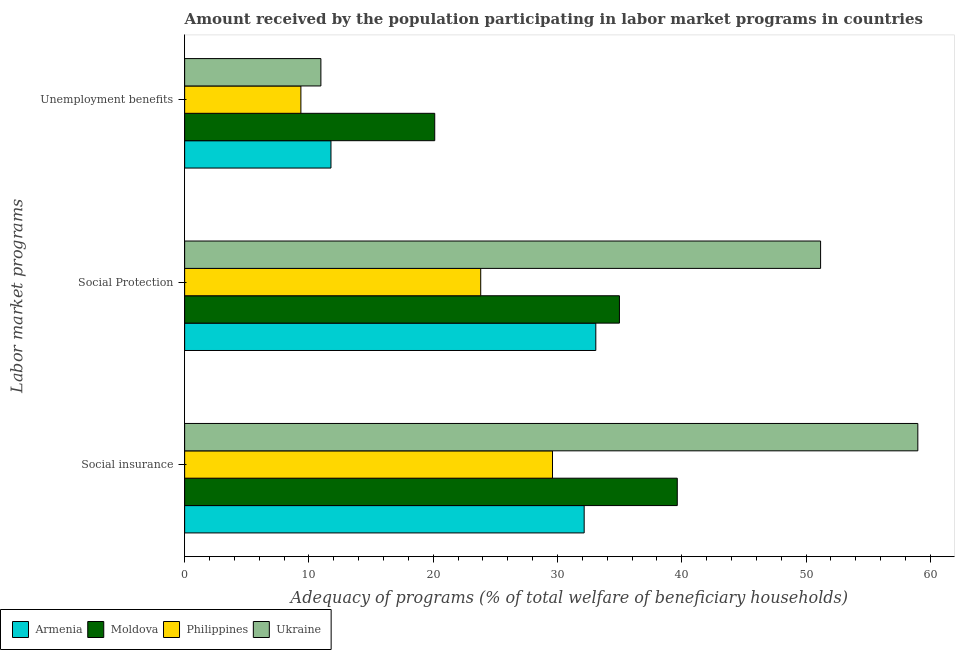Are the number of bars per tick equal to the number of legend labels?
Keep it short and to the point. Yes. Are the number of bars on each tick of the Y-axis equal?
Ensure brevity in your answer.  Yes. How many bars are there on the 1st tick from the top?
Offer a very short reply. 4. How many bars are there on the 1st tick from the bottom?
Offer a terse response. 4. What is the label of the 3rd group of bars from the top?
Make the answer very short. Social insurance. What is the amount received by the population participating in unemployment benefits programs in Moldova?
Provide a succinct answer. 20.12. Across all countries, what is the maximum amount received by the population participating in social insurance programs?
Provide a succinct answer. 58.99. Across all countries, what is the minimum amount received by the population participating in social insurance programs?
Provide a succinct answer. 29.6. In which country was the amount received by the population participating in unemployment benefits programs maximum?
Provide a short and direct response. Moldova. What is the total amount received by the population participating in social insurance programs in the graph?
Keep it short and to the point. 160.38. What is the difference between the amount received by the population participating in social protection programs in Philippines and that in Armenia?
Give a very brief answer. -9.26. What is the difference between the amount received by the population participating in social insurance programs in Armenia and the amount received by the population participating in unemployment benefits programs in Philippines?
Keep it short and to the point. 22.79. What is the average amount received by the population participating in unemployment benefits programs per country?
Offer a terse response. 13.05. What is the difference between the amount received by the population participating in unemployment benefits programs and amount received by the population participating in social protection programs in Armenia?
Provide a short and direct response. -21.31. In how many countries, is the amount received by the population participating in unemployment benefits programs greater than 38 %?
Provide a succinct answer. 0. What is the ratio of the amount received by the population participating in social protection programs in Ukraine to that in Moldova?
Ensure brevity in your answer.  1.46. Is the amount received by the population participating in social protection programs in Philippines less than that in Armenia?
Your answer should be very brief. Yes. Is the difference between the amount received by the population participating in social insurance programs in Ukraine and Armenia greater than the difference between the amount received by the population participating in unemployment benefits programs in Ukraine and Armenia?
Offer a very short reply. Yes. What is the difference between the highest and the second highest amount received by the population participating in social insurance programs?
Ensure brevity in your answer.  19.36. What is the difference between the highest and the lowest amount received by the population participating in social protection programs?
Provide a short and direct response. 27.35. In how many countries, is the amount received by the population participating in social insurance programs greater than the average amount received by the population participating in social insurance programs taken over all countries?
Give a very brief answer. 1. Is the sum of the amount received by the population participating in social insurance programs in Ukraine and Philippines greater than the maximum amount received by the population participating in unemployment benefits programs across all countries?
Keep it short and to the point. Yes. What does the 2nd bar from the top in Social Protection represents?
Your answer should be very brief. Philippines. What does the 4th bar from the bottom in Social Protection represents?
Make the answer very short. Ukraine. Is it the case that in every country, the sum of the amount received by the population participating in social insurance programs and amount received by the population participating in social protection programs is greater than the amount received by the population participating in unemployment benefits programs?
Keep it short and to the point. Yes. How many bars are there?
Offer a very short reply. 12. Are the values on the major ticks of X-axis written in scientific E-notation?
Make the answer very short. No. Does the graph contain any zero values?
Give a very brief answer. No. Where does the legend appear in the graph?
Make the answer very short. Bottom left. How are the legend labels stacked?
Give a very brief answer. Horizontal. What is the title of the graph?
Your answer should be compact. Amount received by the population participating in labor market programs in countries. Does "Dominica" appear as one of the legend labels in the graph?
Offer a terse response. No. What is the label or title of the X-axis?
Your answer should be compact. Adequacy of programs (% of total welfare of beneficiary households). What is the label or title of the Y-axis?
Your answer should be very brief. Labor market programs. What is the Adequacy of programs (% of total welfare of beneficiary households) of Armenia in Social insurance?
Make the answer very short. 32.15. What is the Adequacy of programs (% of total welfare of beneficiary households) in Moldova in Social insurance?
Provide a succinct answer. 39.64. What is the Adequacy of programs (% of total welfare of beneficiary households) of Philippines in Social insurance?
Your answer should be very brief. 29.6. What is the Adequacy of programs (% of total welfare of beneficiary households) in Ukraine in Social insurance?
Your response must be concise. 58.99. What is the Adequacy of programs (% of total welfare of beneficiary households) of Armenia in Social Protection?
Give a very brief answer. 33.08. What is the Adequacy of programs (% of total welfare of beneficiary households) of Moldova in Social Protection?
Provide a succinct answer. 34.98. What is the Adequacy of programs (% of total welfare of beneficiary households) in Philippines in Social Protection?
Provide a short and direct response. 23.82. What is the Adequacy of programs (% of total welfare of beneficiary households) in Ukraine in Social Protection?
Your answer should be compact. 51.17. What is the Adequacy of programs (% of total welfare of beneficiary households) in Armenia in Unemployment benefits?
Give a very brief answer. 11.77. What is the Adequacy of programs (% of total welfare of beneficiary households) of Moldova in Unemployment benefits?
Ensure brevity in your answer.  20.12. What is the Adequacy of programs (% of total welfare of beneficiary households) of Philippines in Unemployment benefits?
Make the answer very short. 9.35. What is the Adequacy of programs (% of total welfare of beneficiary households) in Ukraine in Unemployment benefits?
Give a very brief answer. 10.96. Across all Labor market programs, what is the maximum Adequacy of programs (% of total welfare of beneficiary households) of Armenia?
Your answer should be compact. 33.08. Across all Labor market programs, what is the maximum Adequacy of programs (% of total welfare of beneficiary households) in Moldova?
Your answer should be compact. 39.64. Across all Labor market programs, what is the maximum Adequacy of programs (% of total welfare of beneficiary households) in Philippines?
Provide a succinct answer. 29.6. Across all Labor market programs, what is the maximum Adequacy of programs (% of total welfare of beneficiary households) of Ukraine?
Offer a very short reply. 58.99. Across all Labor market programs, what is the minimum Adequacy of programs (% of total welfare of beneficiary households) of Armenia?
Offer a terse response. 11.77. Across all Labor market programs, what is the minimum Adequacy of programs (% of total welfare of beneficiary households) of Moldova?
Keep it short and to the point. 20.12. Across all Labor market programs, what is the minimum Adequacy of programs (% of total welfare of beneficiary households) in Philippines?
Offer a terse response. 9.35. Across all Labor market programs, what is the minimum Adequacy of programs (% of total welfare of beneficiary households) of Ukraine?
Offer a terse response. 10.96. What is the total Adequacy of programs (% of total welfare of beneficiary households) in Armenia in the graph?
Give a very brief answer. 77.01. What is the total Adequacy of programs (% of total welfare of beneficiary households) in Moldova in the graph?
Provide a short and direct response. 94.75. What is the total Adequacy of programs (% of total welfare of beneficiary households) of Philippines in the graph?
Give a very brief answer. 62.78. What is the total Adequacy of programs (% of total welfare of beneficiary households) of Ukraine in the graph?
Offer a very short reply. 121.13. What is the difference between the Adequacy of programs (% of total welfare of beneficiary households) of Armenia in Social insurance and that in Social Protection?
Provide a succinct answer. -0.94. What is the difference between the Adequacy of programs (% of total welfare of beneficiary households) of Moldova in Social insurance and that in Social Protection?
Provide a succinct answer. 4.65. What is the difference between the Adequacy of programs (% of total welfare of beneficiary households) of Philippines in Social insurance and that in Social Protection?
Your answer should be very brief. 5.78. What is the difference between the Adequacy of programs (% of total welfare of beneficiary households) in Ukraine in Social insurance and that in Social Protection?
Offer a very short reply. 7.82. What is the difference between the Adequacy of programs (% of total welfare of beneficiary households) of Armenia in Social insurance and that in Unemployment benefits?
Offer a terse response. 20.37. What is the difference between the Adequacy of programs (% of total welfare of beneficiary households) of Moldova in Social insurance and that in Unemployment benefits?
Keep it short and to the point. 19.52. What is the difference between the Adequacy of programs (% of total welfare of beneficiary households) of Philippines in Social insurance and that in Unemployment benefits?
Ensure brevity in your answer.  20.25. What is the difference between the Adequacy of programs (% of total welfare of beneficiary households) in Ukraine in Social insurance and that in Unemployment benefits?
Your answer should be compact. 48.03. What is the difference between the Adequacy of programs (% of total welfare of beneficiary households) of Armenia in Social Protection and that in Unemployment benefits?
Ensure brevity in your answer.  21.31. What is the difference between the Adequacy of programs (% of total welfare of beneficiary households) of Moldova in Social Protection and that in Unemployment benefits?
Your answer should be compact. 14.86. What is the difference between the Adequacy of programs (% of total welfare of beneficiary households) in Philippines in Social Protection and that in Unemployment benefits?
Give a very brief answer. 14.47. What is the difference between the Adequacy of programs (% of total welfare of beneficiary households) of Ukraine in Social Protection and that in Unemployment benefits?
Make the answer very short. 40.21. What is the difference between the Adequacy of programs (% of total welfare of beneficiary households) in Armenia in Social insurance and the Adequacy of programs (% of total welfare of beneficiary households) in Moldova in Social Protection?
Provide a succinct answer. -2.84. What is the difference between the Adequacy of programs (% of total welfare of beneficiary households) in Armenia in Social insurance and the Adequacy of programs (% of total welfare of beneficiary households) in Philippines in Social Protection?
Your answer should be compact. 8.32. What is the difference between the Adequacy of programs (% of total welfare of beneficiary households) in Armenia in Social insurance and the Adequacy of programs (% of total welfare of beneficiary households) in Ukraine in Social Protection?
Offer a terse response. -19.02. What is the difference between the Adequacy of programs (% of total welfare of beneficiary households) in Moldova in Social insurance and the Adequacy of programs (% of total welfare of beneficiary households) in Philippines in Social Protection?
Ensure brevity in your answer.  15.81. What is the difference between the Adequacy of programs (% of total welfare of beneficiary households) in Moldova in Social insurance and the Adequacy of programs (% of total welfare of beneficiary households) in Ukraine in Social Protection?
Make the answer very short. -11.53. What is the difference between the Adequacy of programs (% of total welfare of beneficiary households) in Philippines in Social insurance and the Adequacy of programs (% of total welfare of beneficiary households) in Ukraine in Social Protection?
Your answer should be compact. -21.57. What is the difference between the Adequacy of programs (% of total welfare of beneficiary households) of Armenia in Social insurance and the Adequacy of programs (% of total welfare of beneficiary households) of Moldova in Unemployment benefits?
Provide a succinct answer. 12.03. What is the difference between the Adequacy of programs (% of total welfare of beneficiary households) in Armenia in Social insurance and the Adequacy of programs (% of total welfare of beneficiary households) in Philippines in Unemployment benefits?
Your response must be concise. 22.79. What is the difference between the Adequacy of programs (% of total welfare of beneficiary households) in Armenia in Social insurance and the Adequacy of programs (% of total welfare of beneficiary households) in Ukraine in Unemployment benefits?
Provide a succinct answer. 21.19. What is the difference between the Adequacy of programs (% of total welfare of beneficiary households) in Moldova in Social insurance and the Adequacy of programs (% of total welfare of beneficiary households) in Philippines in Unemployment benefits?
Give a very brief answer. 30.28. What is the difference between the Adequacy of programs (% of total welfare of beneficiary households) in Moldova in Social insurance and the Adequacy of programs (% of total welfare of beneficiary households) in Ukraine in Unemployment benefits?
Keep it short and to the point. 28.68. What is the difference between the Adequacy of programs (% of total welfare of beneficiary households) in Philippines in Social insurance and the Adequacy of programs (% of total welfare of beneficiary households) in Ukraine in Unemployment benefits?
Offer a very short reply. 18.64. What is the difference between the Adequacy of programs (% of total welfare of beneficiary households) of Armenia in Social Protection and the Adequacy of programs (% of total welfare of beneficiary households) of Moldova in Unemployment benefits?
Give a very brief answer. 12.96. What is the difference between the Adequacy of programs (% of total welfare of beneficiary households) in Armenia in Social Protection and the Adequacy of programs (% of total welfare of beneficiary households) in Philippines in Unemployment benefits?
Ensure brevity in your answer.  23.73. What is the difference between the Adequacy of programs (% of total welfare of beneficiary households) of Armenia in Social Protection and the Adequacy of programs (% of total welfare of beneficiary households) of Ukraine in Unemployment benefits?
Your response must be concise. 22.12. What is the difference between the Adequacy of programs (% of total welfare of beneficiary households) in Moldova in Social Protection and the Adequacy of programs (% of total welfare of beneficiary households) in Philippines in Unemployment benefits?
Ensure brevity in your answer.  25.63. What is the difference between the Adequacy of programs (% of total welfare of beneficiary households) in Moldova in Social Protection and the Adequacy of programs (% of total welfare of beneficiary households) in Ukraine in Unemployment benefits?
Keep it short and to the point. 24.02. What is the difference between the Adequacy of programs (% of total welfare of beneficiary households) in Philippines in Social Protection and the Adequacy of programs (% of total welfare of beneficiary households) in Ukraine in Unemployment benefits?
Your response must be concise. 12.86. What is the average Adequacy of programs (% of total welfare of beneficiary households) of Armenia per Labor market programs?
Your response must be concise. 25.67. What is the average Adequacy of programs (% of total welfare of beneficiary households) of Moldova per Labor market programs?
Give a very brief answer. 31.58. What is the average Adequacy of programs (% of total welfare of beneficiary households) in Philippines per Labor market programs?
Give a very brief answer. 20.93. What is the average Adequacy of programs (% of total welfare of beneficiary households) in Ukraine per Labor market programs?
Your answer should be very brief. 40.38. What is the difference between the Adequacy of programs (% of total welfare of beneficiary households) in Armenia and Adequacy of programs (% of total welfare of beneficiary households) in Moldova in Social insurance?
Provide a succinct answer. -7.49. What is the difference between the Adequacy of programs (% of total welfare of beneficiary households) of Armenia and Adequacy of programs (% of total welfare of beneficiary households) of Philippines in Social insurance?
Give a very brief answer. 2.55. What is the difference between the Adequacy of programs (% of total welfare of beneficiary households) of Armenia and Adequacy of programs (% of total welfare of beneficiary households) of Ukraine in Social insurance?
Your response must be concise. -26.85. What is the difference between the Adequacy of programs (% of total welfare of beneficiary households) in Moldova and Adequacy of programs (% of total welfare of beneficiary households) in Philippines in Social insurance?
Your answer should be very brief. 10.04. What is the difference between the Adequacy of programs (% of total welfare of beneficiary households) in Moldova and Adequacy of programs (% of total welfare of beneficiary households) in Ukraine in Social insurance?
Provide a short and direct response. -19.36. What is the difference between the Adequacy of programs (% of total welfare of beneficiary households) in Philippines and Adequacy of programs (% of total welfare of beneficiary households) in Ukraine in Social insurance?
Make the answer very short. -29.4. What is the difference between the Adequacy of programs (% of total welfare of beneficiary households) in Armenia and Adequacy of programs (% of total welfare of beneficiary households) in Moldova in Social Protection?
Ensure brevity in your answer.  -1.9. What is the difference between the Adequacy of programs (% of total welfare of beneficiary households) of Armenia and Adequacy of programs (% of total welfare of beneficiary households) of Philippines in Social Protection?
Your response must be concise. 9.26. What is the difference between the Adequacy of programs (% of total welfare of beneficiary households) in Armenia and Adequacy of programs (% of total welfare of beneficiary households) in Ukraine in Social Protection?
Your response must be concise. -18.09. What is the difference between the Adequacy of programs (% of total welfare of beneficiary households) in Moldova and Adequacy of programs (% of total welfare of beneficiary households) in Philippines in Social Protection?
Make the answer very short. 11.16. What is the difference between the Adequacy of programs (% of total welfare of beneficiary households) in Moldova and Adequacy of programs (% of total welfare of beneficiary households) in Ukraine in Social Protection?
Offer a terse response. -16.19. What is the difference between the Adequacy of programs (% of total welfare of beneficiary households) of Philippines and Adequacy of programs (% of total welfare of beneficiary households) of Ukraine in Social Protection?
Keep it short and to the point. -27.35. What is the difference between the Adequacy of programs (% of total welfare of beneficiary households) of Armenia and Adequacy of programs (% of total welfare of beneficiary households) of Moldova in Unemployment benefits?
Offer a very short reply. -8.35. What is the difference between the Adequacy of programs (% of total welfare of beneficiary households) in Armenia and Adequacy of programs (% of total welfare of beneficiary households) in Philippines in Unemployment benefits?
Provide a succinct answer. 2.42. What is the difference between the Adequacy of programs (% of total welfare of beneficiary households) in Armenia and Adequacy of programs (% of total welfare of beneficiary households) in Ukraine in Unemployment benefits?
Keep it short and to the point. 0.81. What is the difference between the Adequacy of programs (% of total welfare of beneficiary households) in Moldova and Adequacy of programs (% of total welfare of beneficiary households) in Philippines in Unemployment benefits?
Offer a terse response. 10.77. What is the difference between the Adequacy of programs (% of total welfare of beneficiary households) of Moldova and Adequacy of programs (% of total welfare of beneficiary households) of Ukraine in Unemployment benefits?
Your response must be concise. 9.16. What is the difference between the Adequacy of programs (% of total welfare of beneficiary households) of Philippines and Adequacy of programs (% of total welfare of beneficiary households) of Ukraine in Unemployment benefits?
Ensure brevity in your answer.  -1.61. What is the ratio of the Adequacy of programs (% of total welfare of beneficiary households) in Armenia in Social insurance to that in Social Protection?
Provide a succinct answer. 0.97. What is the ratio of the Adequacy of programs (% of total welfare of beneficiary households) in Moldova in Social insurance to that in Social Protection?
Provide a succinct answer. 1.13. What is the ratio of the Adequacy of programs (% of total welfare of beneficiary households) in Philippines in Social insurance to that in Social Protection?
Make the answer very short. 1.24. What is the ratio of the Adequacy of programs (% of total welfare of beneficiary households) of Ukraine in Social insurance to that in Social Protection?
Make the answer very short. 1.15. What is the ratio of the Adequacy of programs (% of total welfare of beneficiary households) of Armenia in Social insurance to that in Unemployment benefits?
Give a very brief answer. 2.73. What is the ratio of the Adequacy of programs (% of total welfare of beneficiary households) in Moldova in Social insurance to that in Unemployment benefits?
Your response must be concise. 1.97. What is the ratio of the Adequacy of programs (% of total welfare of beneficiary households) in Philippines in Social insurance to that in Unemployment benefits?
Your answer should be very brief. 3.16. What is the ratio of the Adequacy of programs (% of total welfare of beneficiary households) in Ukraine in Social insurance to that in Unemployment benefits?
Give a very brief answer. 5.38. What is the ratio of the Adequacy of programs (% of total welfare of beneficiary households) in Armenia in Social Protection to that in Unemployment benefits?
Offer a terse response. 2.81. What is the ratio of the Adequacy of programs (% of total welfare of beneficiary households) in Moldova in Social Protection to that in Unemployment benefits?
Make the answer very short. 1.74. What is the ratio of the Adequacy of programs (% of total welfare of beneficiary households) of Philippines in Social Protection to that in Unemployment benefits?
Keep it short and to the point. 2.55. What is the ratio of the Adequacy of programs (% of total welfare of beneficiary households) of Ukraine in Social Protection to that in Unemployment benefits?
Your answer should be compact. 4.67. What is the difference between the highest and the second highest Adequacy of programs (% of total welfare of beneficiary households) in Armenia?
Your response must be concise. 0.94. What is the difference between the highest and the second highest Adequacy of programs (% of total welfare of beneficiary households) in Moldova?
Ensure brevity in your answer.  4.65. What is the difference between the highest and the second highest Adequacy of programs (% of total welfare of beneficiary households) of Philippines?
Your response must be concise. 5.78. What is the difference between the highest and the second highest Adequacy of programs (% of total welfare of beneficiary households) of Ukraine?
Offer a terse response. 7.82. What is the difference between the highest and the lowest Adequacy of programs (% of total welfare of beneficiary households) of Armenia?
Offer a terse response. 21.31. What is the difference between the highest and the lowest Adequacy of programs (% of total welfare of beneficiary households) of Moldova?
Ensure brevity in your answer.  19.52. What is the difference between the highest and the lowest Adequacy of programs (% of total welfare of beneficiary households) in Philippines?
Give a very brief answer. 20.25. What is the difference between the highest and the lowest Adequacy of programs (% of total welfare of beneficiary households) in Ukraine?
Your answer should be very brief. 48.03. 